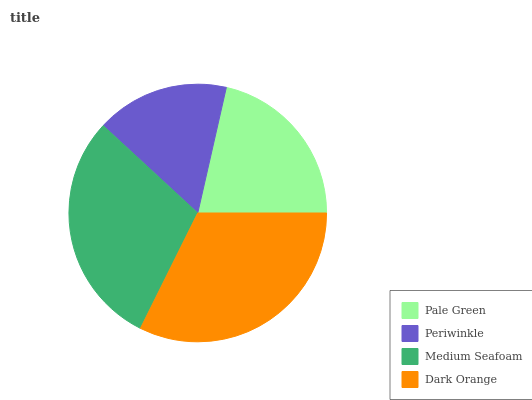Is Periwinkle the minimum?
Answer yes or no. Yes. Is Dark Orange the maximum?
Answer yes or no. Yes. Is Medium Seafoam the minimum?
Answer yes or no. No. Is Medium Seafoam the maximum?
Answer yes or no. No. Is Medium Seafoam greater than Periwinkle?
Answer yes or no. Yes. Is Periwinkle less than Medium Seafoam?
Answer yes or no. Yes. Is Periwinkle greater than Medium Seafoam?
Answer yes or no. No. Is Medium Seafoam less than Periwinkle?
Answer yes or no. No. Is Medium Seafoam the high median?
Answer yes or no. Yes. Is Pale Green the low median?
Answer yes or no. Yes. Is Pale Green the high median?
Answer yes or no. No. Is Dark Orange the low median?
Answer yes or no. No. 